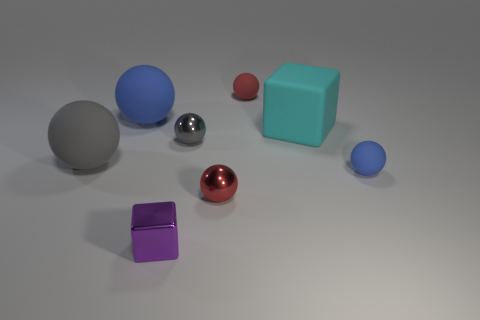Are there any other blue matte things of the same shape as the tiny blue rubber thing?
Give a very brief answer. Yes. How many other objects are there of the same color as the metal block?
Provide a succinct answer. 0. There is a small matte ball that is behind the blue ball to the left of the blue matte sphere right of the tiny cube; what is its color?
Provide a short and direct response. Red. Is the number of tiny things that are on the right side of the small purple thing the same as the number of purple things?
Offer a terse response. No. Is the size of the gray object that is behind the gray matte sphere the same as the small blue rubber thing?
Give a very brief answer. Yes. What number of green shiny things are there?
Offer a very short reply. 0. What number of balls are both left of the shiny cube and to the right of the large cyan object?
Your answer should be very brief. 0. Are there any gray spheres that have the same material as the small blue ball?
Give a very brief answer. Yes. There is a tiny red object in front of the gray object on the right side of the small purple shiny cube; what is its material?
Provide a succinct answer. Metal. Are there the same number of tiny metal blocks behind the tiny purple cube and cyan rubber cubes that are behind the small red rubber object?
Offer a terse response. Yes. 